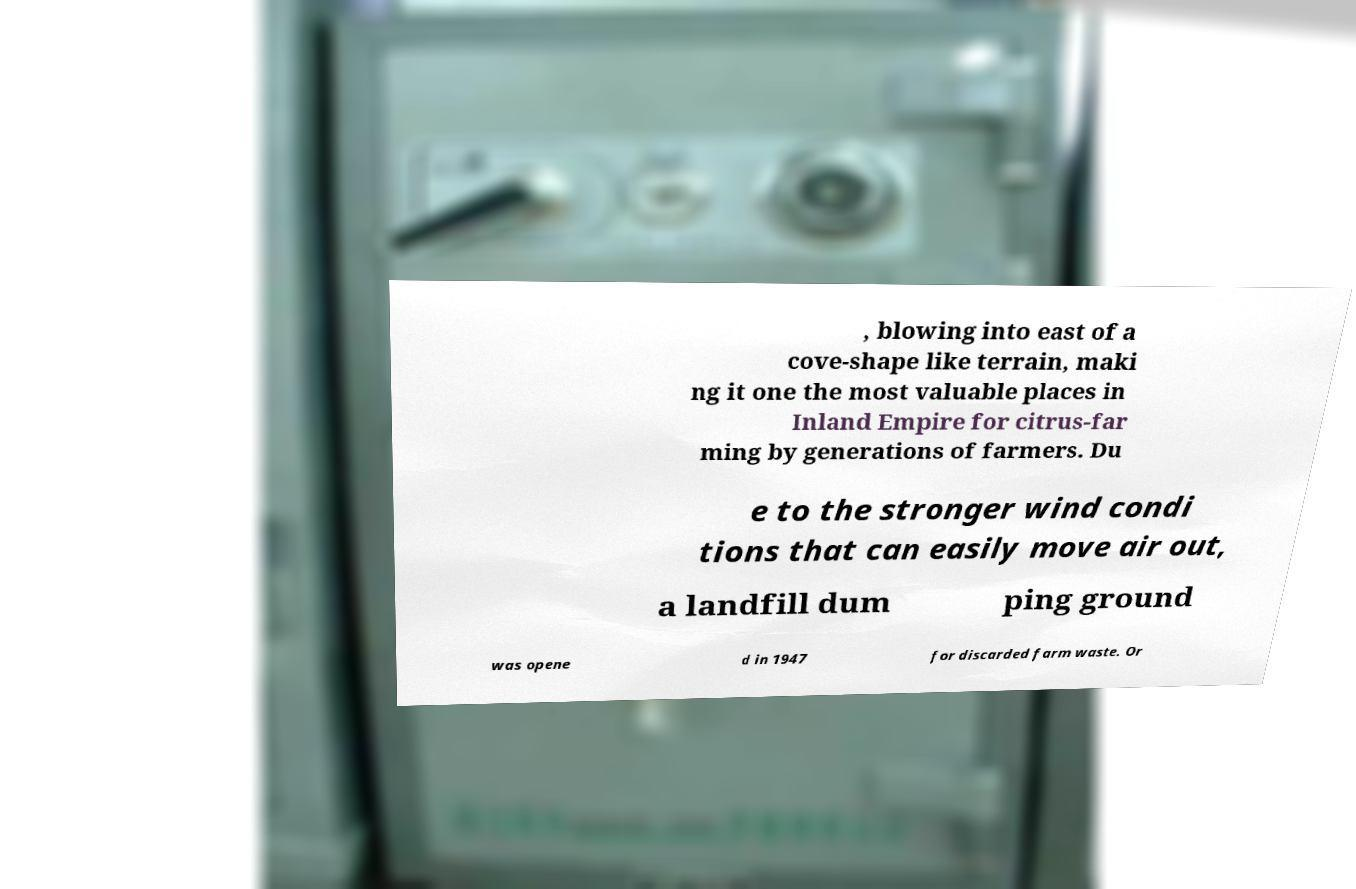What messages or text are displayed in this image? I need them in a readable, typed format. , blowing into east of a cove-shape like terrain, maki ng it one the most valuable places in Inland Empire for citrus-far ming by generations of farmers. Du e to the stronger wind condi tions that can easily move air out, a landfill dum ping ground was opene d in 1947 for discarded farm waste. Or 